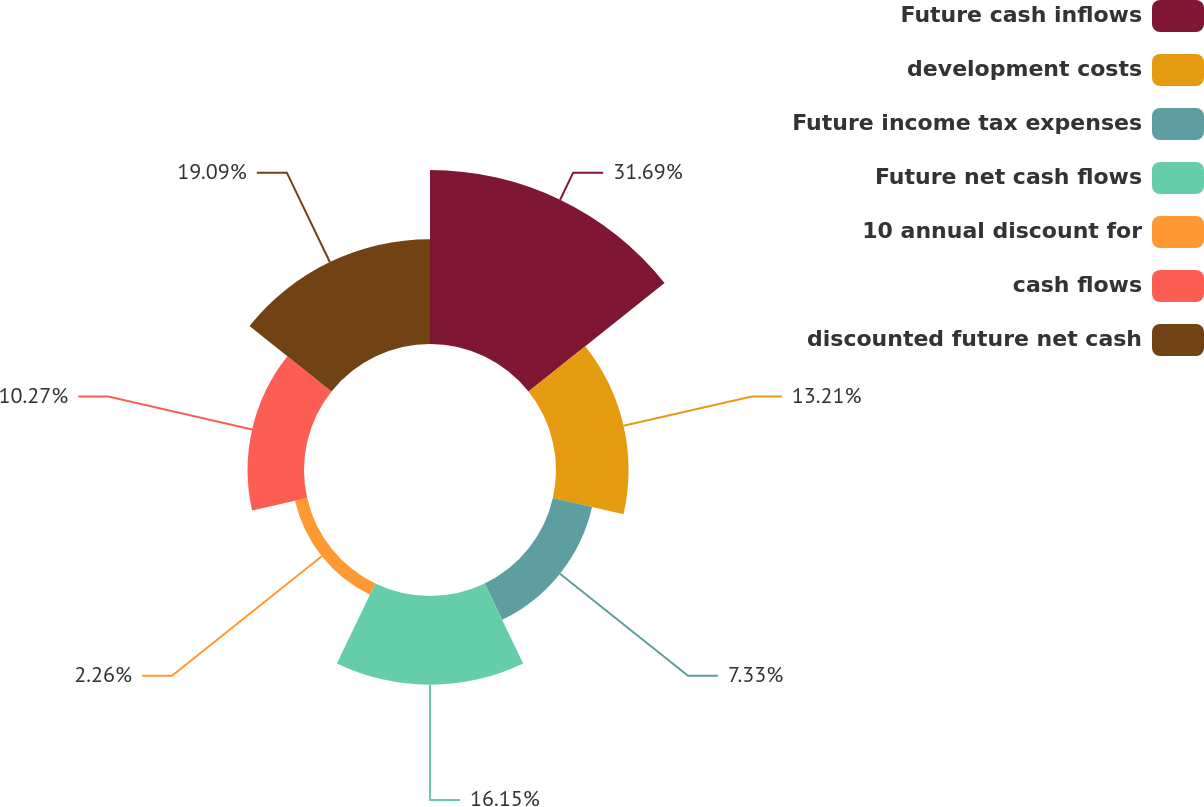<chart> <loc_0><loc_0><loc_500><loc_500><pie_chart><fcel>Future cash inflows<fcel>development costs<fcel>Future income tax expenses<fcel>Future net cash flows<fcel>10 annual discount for<fcel>cash flows<fcel>discounted future net cash<nl><fcel>31.68%<fcel>13.21%<fcel>7.33%<fcel>16.15%<fcel>2.26%<fcel>10.27%<fcel>19.09%<nl></chart> 